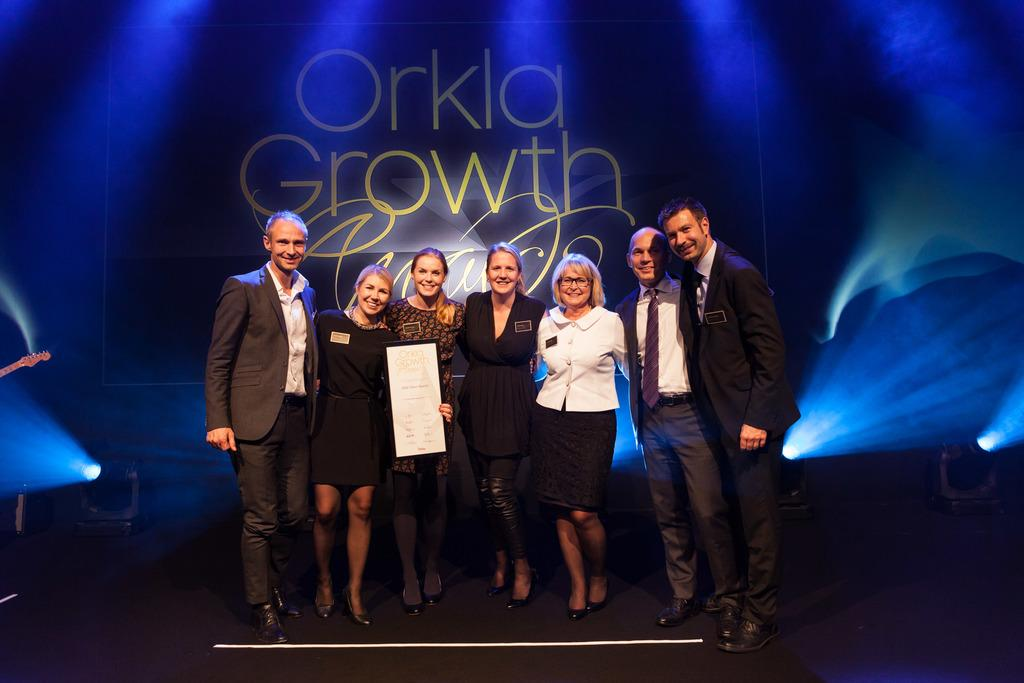How many people are in the image? There is a group of persons in the image. What are the people in the image doing? The persons are standing and smiling. What can be seen in the background of the image? There are lights and a banner at the back of the group. What is written on the banner? There is writing on the banner. What type of lace can be seen on the snails in the image? There are no snails or lace present in the image. What statement is being made by the group in the image? The image does not provide any information about a statement being made by the group. 